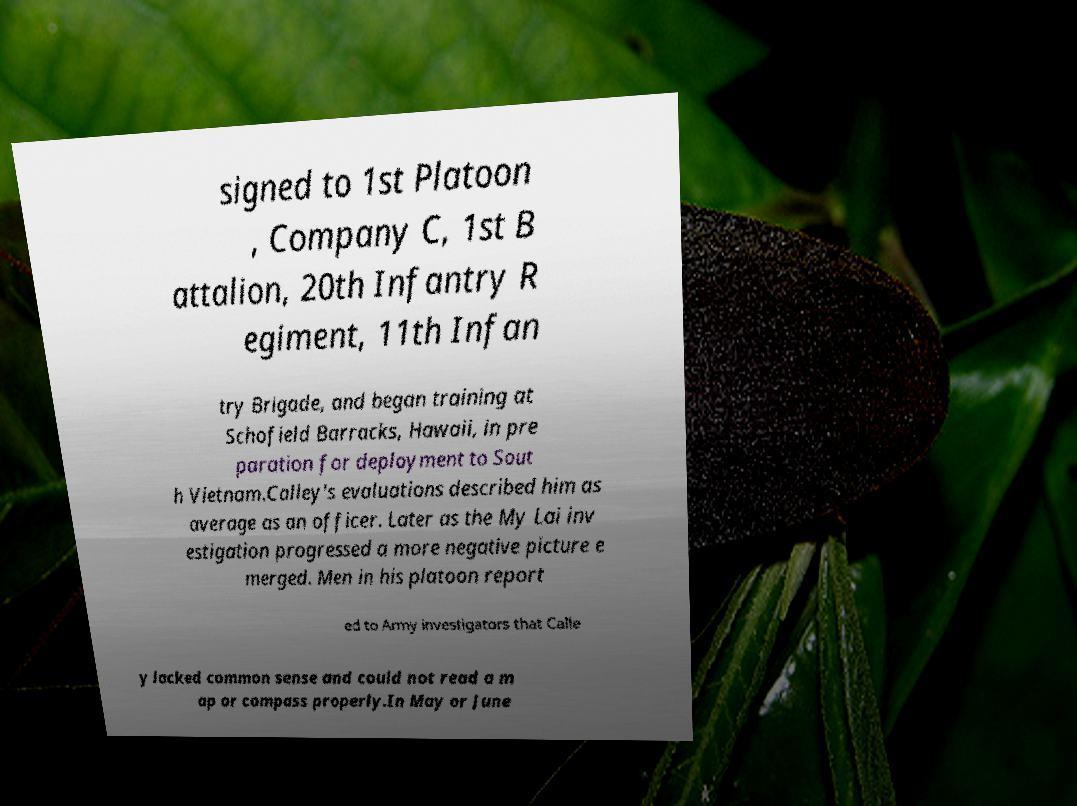I need the written content from this picture converted into text. Can you do that? signed to 1st Platoon , Company C, 1st B attalion, 20th Infantry R egiment, 11th Infan try Brigade, and began training at Schofield Barracks, Hawaii, in pre paration for deployment to Sout h Vietnam.Calley's evaluations described him as average as an officer. Later as the My Lai inv estigation progressed a more negative picture e merged. Men in his platoon report ed to Army investigators that Calle y lacked common sense and could not read a m ap or compass properly.In May or June 